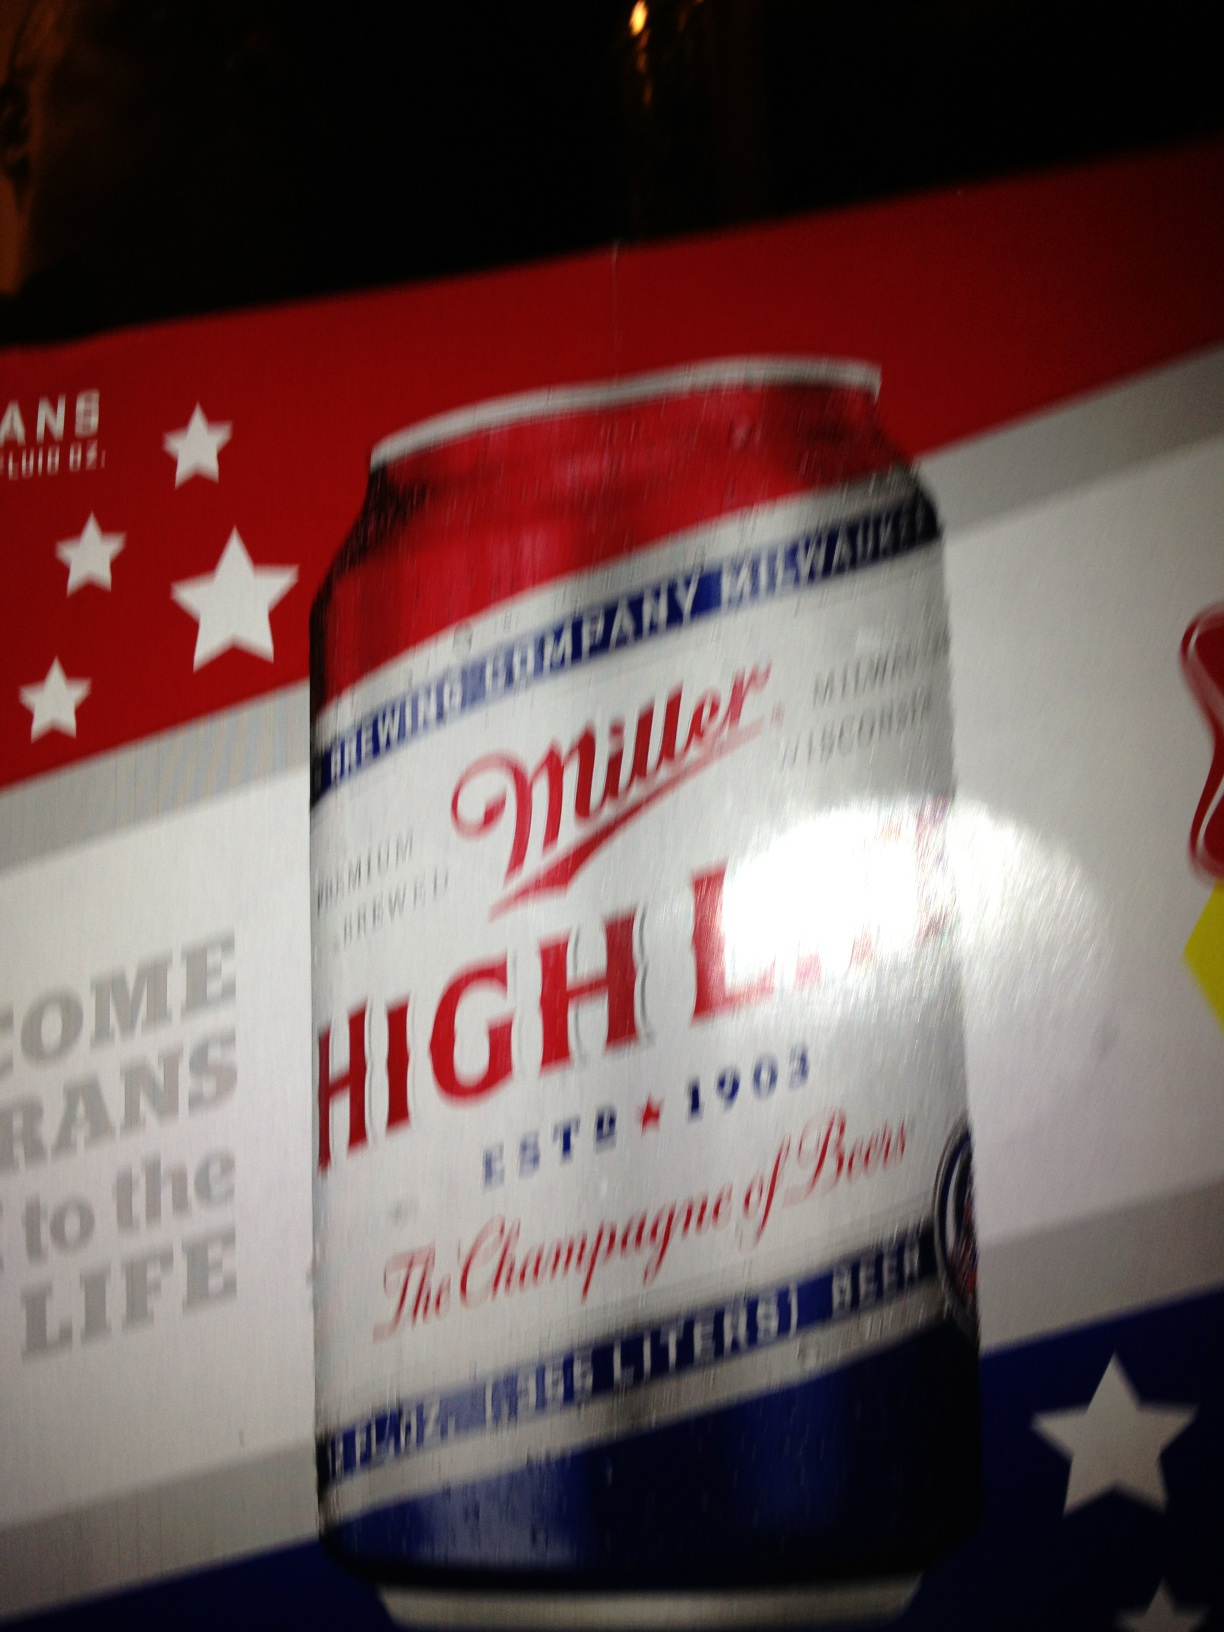Can you tell me more about the brand of beer shown in this image? Certainly! The brand is Miller High Life, which debuted in 1903 and has become a classic American beer. It's well-known for its distinctive clear glass bottles and cans, symbolic advertising, and its place in Americana. 